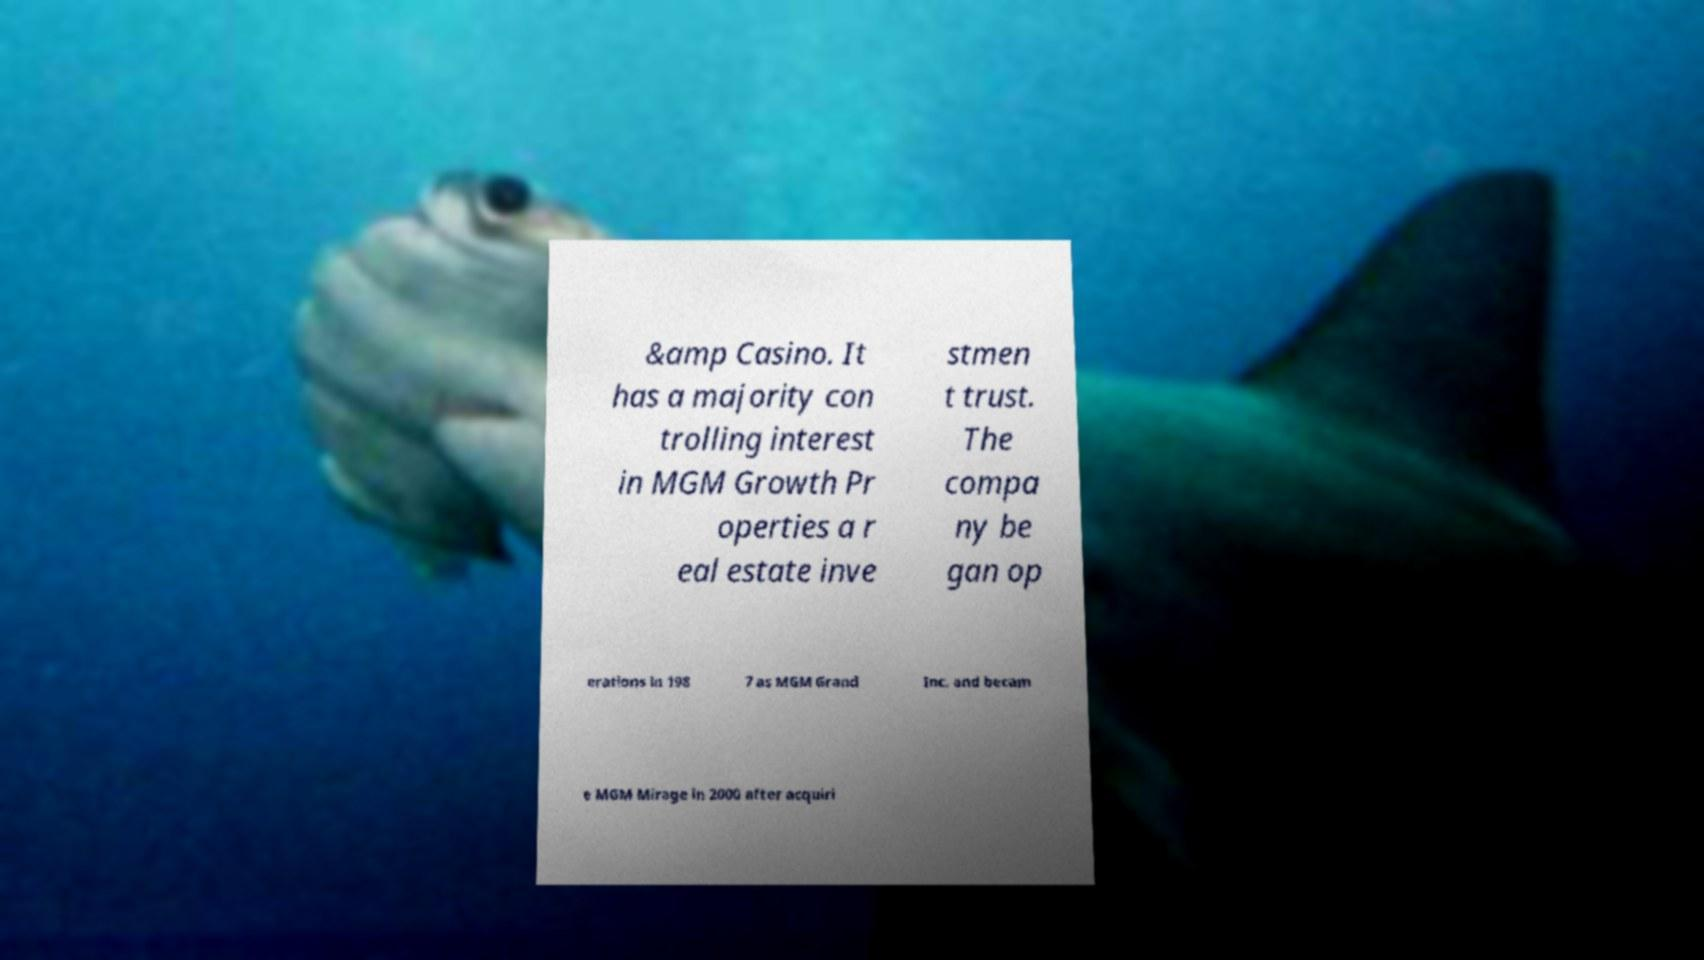There's text embedded in this image that I need extracted. Can you transcribe it verbatim? &amp Casino. It has a majority con trolling interest in MGM Growth Pr operties a r eal estate inve stmen t trust. The compa ny be gan op erations in 198 7 as MGM Grand Inc. and becam e MGM Mirage in 2000 after acquiri 